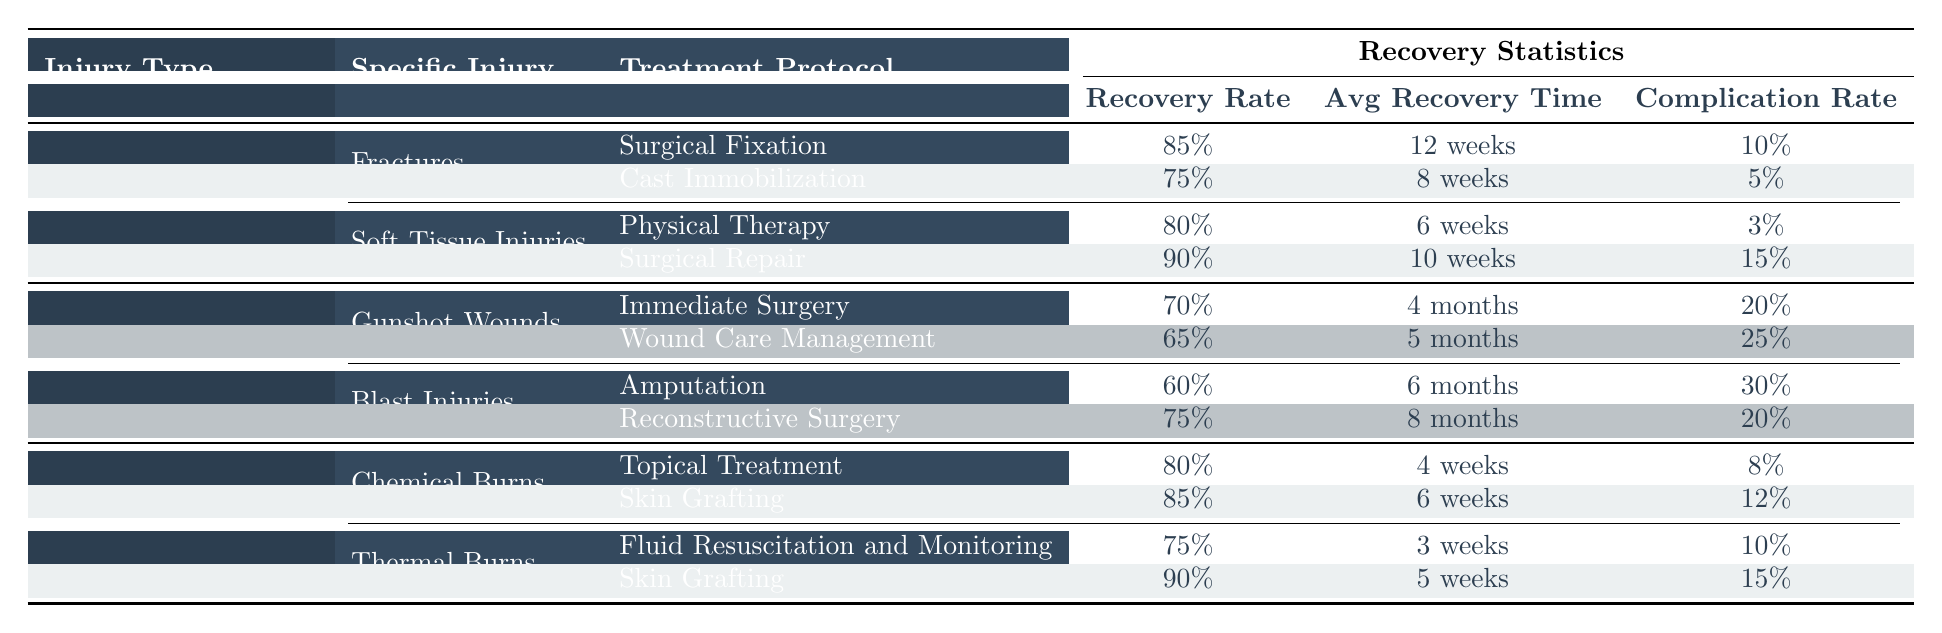What is the recovery rate for fractures with surgical fixation? The table indicates that the recovery rate for fractures treated with surgical fixation is listed directly under the "Recovery Rate" column for that treatment protocol. It shows 85%.
Answer: 85% Which treatment protocol for soft tissue injuries has the highest recovery rate? By comparing the recovery rates of both treatment protocols for soft tissue injuries, the table shows that surgical repair has a recovery rate of 90%, which is higher than the physical therapy rate of 80%.
Answer: Surgical repair What is the average recovery time for gunshot wounds treated with wound care management? The average recovery time for gunshot wounds treated with wound care management is found in the "Average Recovery Time" column of the corresponding row, which is 5 months.
Answer: 5 months Are complication rates higher for blast injuries treated with amputation compared to those treated with reconstructive surgery? The complication rate for blast injuries treated with amputation is 30%, while the rate for reconstructive surgery is 20%. Since 30% is greater than 20%, the answer is yes.
Answer: Yes What is the difference in recovery rates between skin grafting for chemical burns and thermal burns? The recovery rate for skin grafting for chemical burns is 85%, and for thermal burns, it is 90%. To find the difference, we subtract: 90% - 85% = 5%.
Answer: 5% Which injury type has the longest average recovery time overall? To determine the injury type with the longest average recovery time, we need to look at the average recovery times listed for each treatment protocol across all injury types. The longest recovery time is 6 months for blast injuries (amputation) and is 4 months for gunshot wounds (immediate surgery). Therefore, the combined data shows that traumatic injuries (blast injuries with amputation) has the longest time.
Answer: Traumatic Injuries Is the complication rate for cast immobilization lower than that for surgical repair of soft tissue injuries? The complication rate for cast immobilization is 5%, while for surgical repair of soft tissue injuries, it is 15%. Since 5% is less than 15%, the statement is true.
Answer: Yes What is the average recovery time for recovery protocols under orthopedic injuries? To find the average recovery time for recovery protocols under orthopedic injuries, we need to add the average recovery times for both fractures and soft tissue injuries. Fractures average recovery times are 12 weeks (surgical fixation) and 8 weeks (cast immobilization), totaling 20 weeks, plus 6 weeks (physical therapy) and 10 weeks (surgical repair) for soft tissue injuries, totaling another 16 weeks. This leads to a combined total of 36 weeks for 4 groups, so the average is 36 weeks / 4 = 9 weeks.
Answer: 9 weeks 